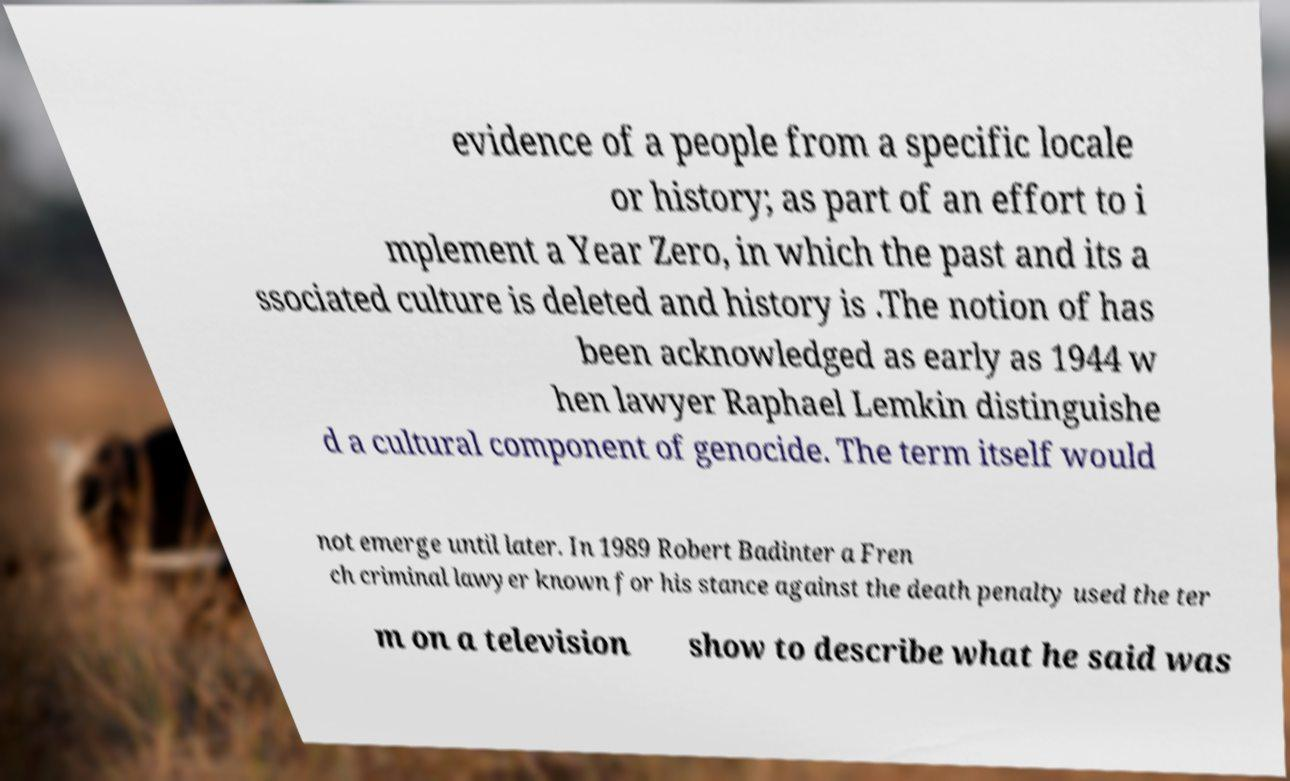Please read and relay the text visible in this image. What does it say? evidence of a people from a specific locale or history; as part of an effort to i mplement a Year Zero, in which the past and its a ssociated culture is deleted and history is .The notion of has been acknowledged as early as 1944 w hen lawyer Raphael Lemkin distinguishe d a cultural component of genocide. The term itself would not emerge until later. In 1989 Robert Badinter a Fren ch criminal lawyer known for his stance against the death penalty used the ter m on a television show to describe what he said was 